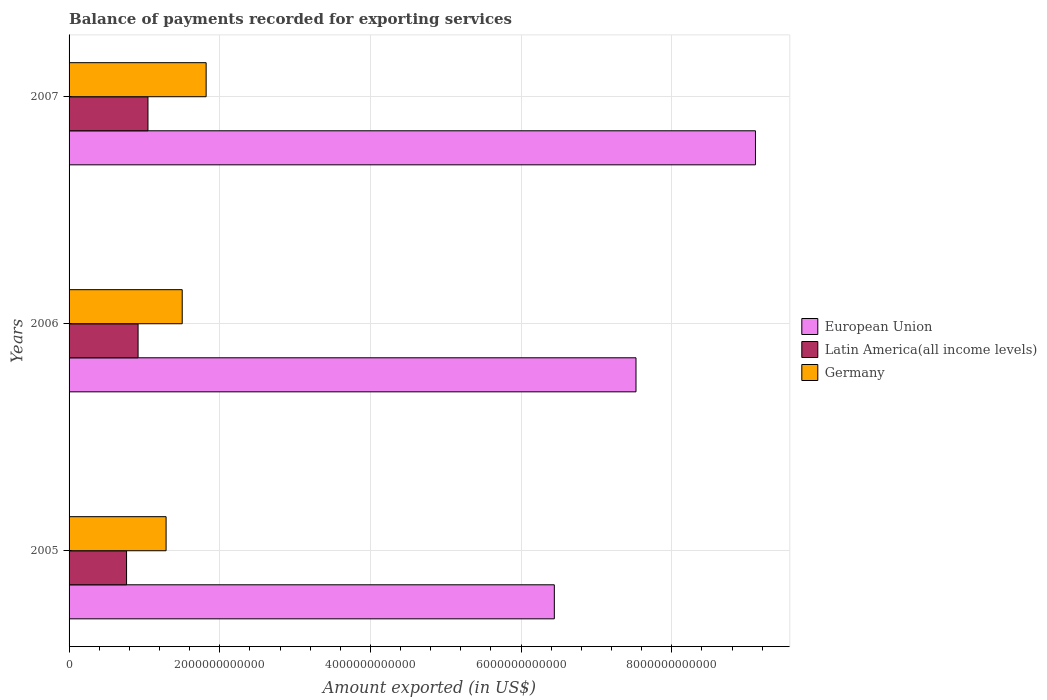How many groups of bars are there?
Offer a terse response. 3. Are the number of bars per tick equal to the number of legend labels?
Offer a very short reply. Yes. Are the number of bars on each tick of the Y-axis equal?
Provide a succinct answer. Yes. What is the amount exported in Germany in 2005?
Offer a terse response. 1.29e+12. Across all years, what is the maximum amount exported in Germany?
Provide a succinct answer. 1.82e+12. Across all years, what is the minimum amount exported in Latin America(all income levels)?
Your answer should be very brief. 7.63e+11. In which year was the amount exported in European Union maximum?
Make the answer very short. 2007. What is the total amount exported in Germany in the graph?
Provide a short and direct response. 4.61e+12. What is the difference between the amount exported in Germany in 2006 and that in 2007?
Offer a very short reply. -3.18e+11. What is the difference between the amount exported in European Union in 2005 and the amount exported in Latin America(all income levels) in 2007?
Your response must be concise. 5.39e+12. What is the average amount exported in European Union per year?
Your answer should be compact. 7.69e+12. In the year 2006, what is the difference between the amount exported in European Union and amount exported in Latin America(all income levels)?
Offer a very short reply. 6.61e+12. What is the ratio of the amount exported in Germany in 2005 to that in 2007?
Offer a terse response. 0.71. Is the amount exported in Latin America(all income levels) in 2005 less than that in 2006?
Give a very brief answer. Yes. Is the difference between the amount exported in European Union in 2006 and 2007 greater than the difference between the amount exported in Latin America(all income levels) in 2006 and 2007?
Make the answer very short. No. What is the difference between the highest and the second highest amount exported in Latin America(all income levels)?
Your answer should be compact. 1.31e+11. What is the difference between the highest and the lowest amount exported in European Union?
Offer a terse response. 2.67e+12. In how many years, is the amount exported in Germany greater than the average amount exported in Germany taken over all years?
Your answer should be very brief. 1. Is the sum of the amount exported in European Union in 2005 and 2006 greater than the maximum amount exported in Germany across all years?
Keep it short and to the point. Yes. What does the 2nd bar from the bottom in 2005 represents?
Ensure brevity in your answer.  Latin America(all income levels). Is it the case that in every year, the sum of the amount exported in Latin America(all income levels) and amount exported in European Union is greater than the amount exported in Germany?
Provide a short and direct response. Yes. How many bars are there?
Your response must be concise. 9. Are all the bars in the graph horizontal?
Provide a succinct answer. Yes. What is the difference between two consecutive major ticks on the X-axis?
Your answer should be compact. 2.00e+12. Where does the legend appear in the graph?
Give a very brief answer. Center right. What is the title of the graph?
Your answer should be very brief. Balance of payments recorded for exporting services. Does "Djibouti" appear as one of the legend labels in the graph?
Provide a succinct answer. No. What is the label or title of the X-axis?
Provide a succinct answer. Amount exported (in US$). What is the Amount exported (in US$) in European Union in 2005?
Ensure brevity in your answer.  6.44e+12. What is the Amount exported (in US$) of Latin America(all income levels) in 2005?
Keep it short and to the point. 7.63e+11. What is the Amount exported (in US$) of Germany in 2005?
Offer a very short reply. 1.29e+12. What is the Amount exported (in US$) in European Union in 2006?
Ensure brevity in your answer.  7.53e+12. What is the Amount exported (in US$) of Latin America(all income levels) in 2006?
Give a very brief answer. 9.16e+11. What is the Amount exported (in US$) of Germany in 2006?
Ensure brevity in your answer.  1.50e+12. What is the Amount exported (in US$) of European Union in 2007?
Your answer should be very brief. 9.11e+12. What is the Amount exported (in US$) of Latin America(all income levels) in 2007?
Your answer should be very brief. 1.05e+12. What is the Amount exported (in US$) of Germany in 2007?
Ensure brevity in your answer.  1.82e+12. Across all years, what is the maximum Amount exported (in US$) in European Union?
Your answer should be very brief. 9.11e+12. Across all years, what is the maximum Amount exported (in US$) of Latin America(all income levels)?
Give a very brief answer. 1.05e+12. Across all years, what is the maximum Amount exported (in US$) of Germany?
Provide a succinct answer. 1.82e+12. Across all years, what is the minimum Amount exported (in US$) in European Union?
Provide a succinct answer. 6.44e+12. Across all years, what is the minimum Amount exported (in US$) in Latin America(all income levels)?
Your answer should be very brief. 7.63e+11. Across all years, what is the minimum Amount exported (in US$) in Germany?
Provide a succinct answer. 1.29e+12. What is the total Amount exported (in US$) of European Union in the graph?
Ensure brevity in your answer.  2.31e+13. What is the total Amount exported (in US$) in Latin America(all income levels) in the graph?
Your answer should be very brief. 2.73e+12. What is the total Amount exported (in US$) of Germany in the graph?
Offer a terse response. 4.61e+12. What is the difference between the Amount exported (in US$) of European Union in 2005 and that in 2006?
Keep it short and to the point. -1.08e+12. What is the difference between the Amount exported (in US$) in Latin America(all income levels) in 2005 and that in 2006?
Your answer should be very brief. -1.53e+11. What is the difference between the Amount exported (in US$) of Germany in 2005 and that in 2006?
Make the answer very short. -2.14e+11. What is the difference between the Amount exported (in US$) in European Union in 2005 and that in 2007?
Offer a very short reply. -2.67e+12. What is the difference between the Amount exported (in US$) in Latin America(all income levels) in 2005 and that in 2007?
Offer a very short reply. -2.84e+11. What is the difference between the Amount exported (in US$) in Germany in 2005 and that in 2007?
Give a very brief answer. -5.32e+11. What is the difference between the Amount exported (in US$) of European Union in 2006 and that in 2007?
Your response must be concise. -1.59e+12. What is the difference between the Amount exported (in US$) in Latin America(all income levels) in 2006 and that in 2007?
Provide a short and direct response. -1.31e+11. What is the difference between the Amount exported (in US$) of Germany in 2006 and that in 2007?
Give a very brief answer. -3.18e+11. What is the difference between the Amount exported (in US$) of European Union in 2005 and the Amount exported (in US$) of Latin America(all income levels) in 2006?
Make the answer very short. 5.53e+12. What is the difference between the Amount exported (in US$) in European Union in 2005 and the Amount exported (in US$) in Germany in 2006?
Give a very brief answer. 4.94e+12. What is the difference between the Amount exported (in US$) of Latin America(all income levels) in 2005 and the Amount exported (in US$) of Germany in 2006?
Provide a succinct answer. -7.39e+11. What is the difference between the Amount exported (in US$) in European Union in 2005 and the Amount exported (in US$) in Latin America(all income levels) in 2007?
Provide a short and direct response. 5.39e+12. What is the difference between the Amount exported (in US$) of European Union in 2005 and the Amount exported (in US$) of Germany in 2007?
Your answer should be very brief. 4.62e+12. What is the difference between the Amount exported (in US$) in Latin America(all income levels) in 2005 and the Amount exported (in US$) in Germany in 2007?
Your answer should be very brief. -1.06e+12. What is the difference between the Amount exported (in US$) of European Union in 2006 and the Amount exported (in US$) of Latin America(all income levels) in 2007?
Your answer should be compact. 6.48e+12. What is the difference between the Amount exported (in US$) in European Union in 2006 and the Amount exported (in US$) in Germany in 2007?
Your answer should be very brief. 5.71e+12. What is the difference between the Amount exported (in US$) of Latin America(all income levels) in 2006 and the Amount exported (in US$) of Germany in 2007?
Your answer should be very brief. -9.04e+11. What is the average Amount exported (in US$) of European Union per year?
Ensure brevity in your answer.  7.69e+12. What is the average Amount exported (in US$) of Latin America(all income levels) per year?
Your answer should be very brief. 9.09e+11. What is the average Amount exported (in US$) of Germany per year?
Offer a very short reply. 1.54e+12. In the year 2005, what is the difference between the Amount exported (in US$) in European Union and Amount exported (in US$) in Latin America(all income levels)?
Your answer should be compact. 5.68e+12. In the year 2005, what is the difference between the Amount exported (in US$) in European Union and Amount exported (in US$) in Germany?
Make the answer very short. 5.15e+12. In the year 2005, what is the difference between the Amount exported (in US$) in Latin America(all income levels) and Amount exported (in US$) in Germany?
Give a very brief answer. -5.25e+11. In the year 2006, what is the difference between the Amount exported (in US$) in European Union and Amount exported (in US$) in Latin America(all income levels)?
Provide a short and direct response. 6.61e+12. In the year 2006, what is the difference between the Amount exported (in US$) of European Union and Amount exported (in US$) of Germany?
Your answer should be compact. 6.02e+12. In the year 2006, what is the difference between the Amount exported (in US$) in Latin America(all income levels) and Amount exported (in US$) in Germany?
Your response must be concise. -5.86e+11. In the year 2007, what is the difference between the Amount exported (in US$) of European Union and Amount exported (in US$) of Latin America(all income levels)?
Provide a short and direct response. 8.06e+12. In the year 2007, what is the difference between the Amount exported (in US$) of European Union and Amount exported (in US$) of Germany?
Your answer should be compact. 7.29e+12. In the year 2007, what is the difference between the Amount exported (in US$) of Latin America(all income levels) and Amount exported (in US$) of Germany?
Your answer should be compact. -7.72e+11. What is the ratio of the Amount exported (in US$) in European Union in 2005 to that in 2006?
Keep it short and to the point. 0.86. What is the ratio of the Amount exported (in US$) in Latin America(all income levels) in 2005 to that in 2006?
Ensure brevity in your answer.  0.83. What is the ratio of the Amount exported (in US$) in Germany in 2005 to that in 2006?
Your answer should be very brief. 0.86. What is the ratio of the Amount exported (in US$) in European Union in 2005 to that in 2007?
Make the answer very short. 0.71. What is the ratio of the Amount exported (in US$) of Latin America(all income levels) in 2005 to that in 2007?
Your answer should be compact. 0.73. What is the ratio of the Amount exported (in US$) of Germany in 2005 to that in 2007?
Offer a very short reply. 0.71. What is the ratio of the Amount exported (in US$) of European Union in 2006 to that in 2007?
Your answer should be compact. 0.83. What is the ratio of the Amount exported (in US$) in Latin America(all income levels) in 2006 to that in 2007?
Keep it short and to the point. 0.87. What is the ratio of the Amount exported (in US$) in Germany in 2006 to that in 2007?
Keep it short and to the point. 0.83. What is the difference between the highest and the second highest Amount exported (in US$) of European Union?
Keep it short and to the point. 1.59e+12. What is the difference between the highest and the second highest Amount exported (in US$) in Latin America(all income levels)?
Keep it short and to the point. 1.31e+11. What is the difference between the highest and the second highest Amount exported (in US$) in Germany?
Offer a terse response. 3.18e+11. What is the difference between the highest and the lowest Amount exported (in US$) of European Union?
Your response must be concise. 2.67e+12. What is the difference between the highest and the lowest Amount exported (in US$) in Latin America(all income levels)?
Your answer should be compact. 2.84e+11. What is the difference between the highest and the lowest Amount exported (in US$) of Germany?
Make the answer very short. 5.32e+11. 